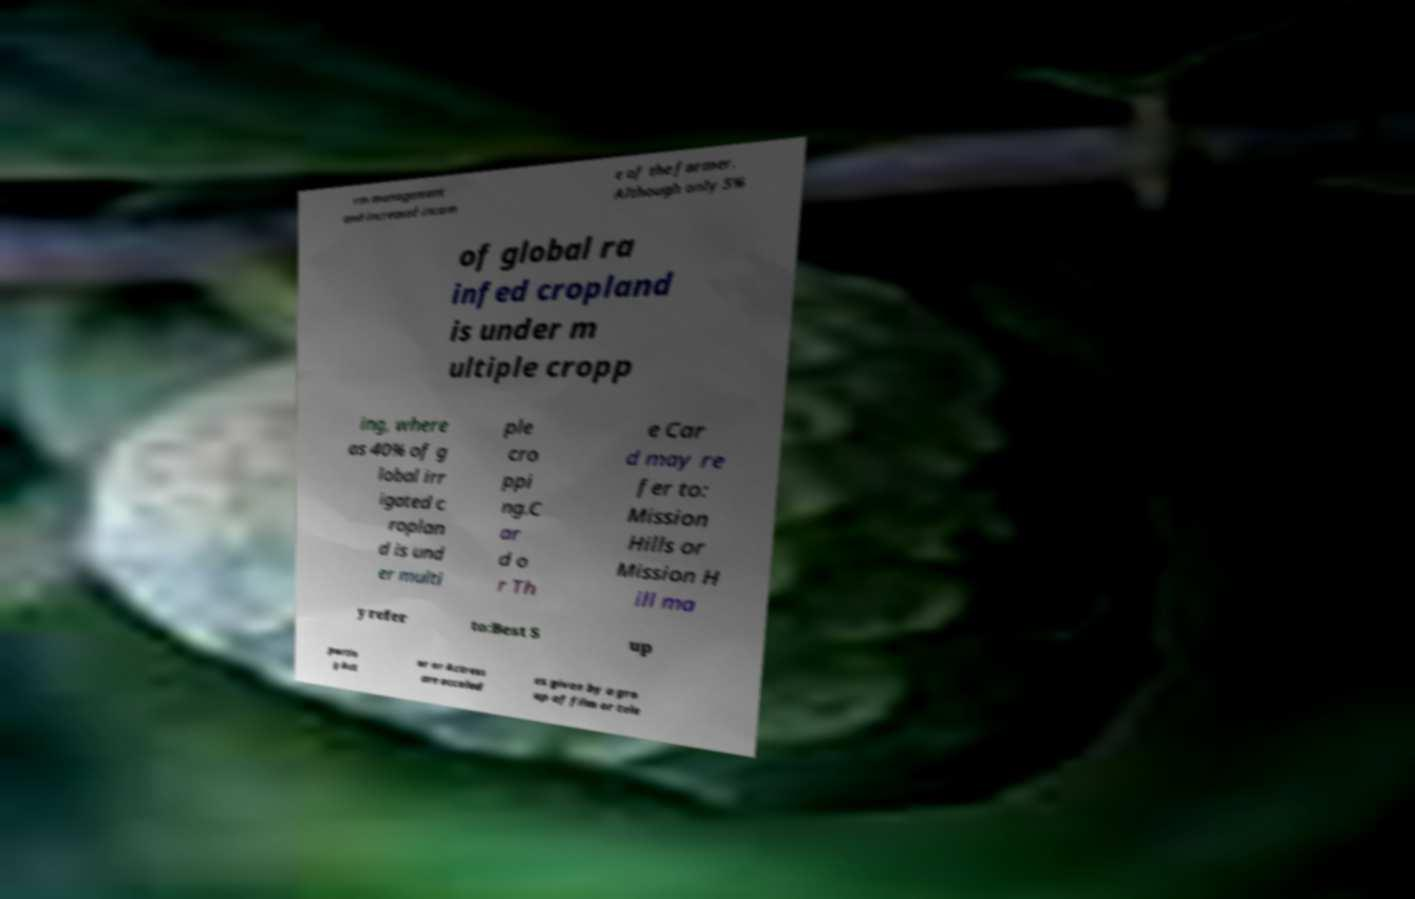Can you read and provide the text displayed in the image?This photo seems to have some interesting text. Can you extract and type it out for me? rm management and increased incom e of the farmer. Although only 5% of global ra infed cropland is under m ultiple cropp ing, where as 40% of g lobal irr igated c roplan d is und er multi ple cro ppi ng.C ar d o r Th e Car d may re fer to: Mission Hills or Mission H ill ma y refer to:Best S up portin g Act or or Actress are accolad es given by a gro up of film or tele 